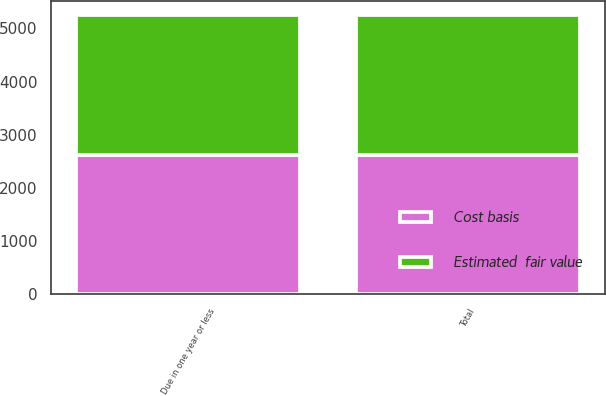<chart> <loc_0><loc_0><loc_500><loc_500><stacked_bar_chart><ecel><fcel>Due in one year or less<fcel>Total<nl><fcel>Cost basis<fcel>2610<fcel>2610<nl><fcel>Estimated  fair value<fcel>2644<fcel>2644<nl></chart> 